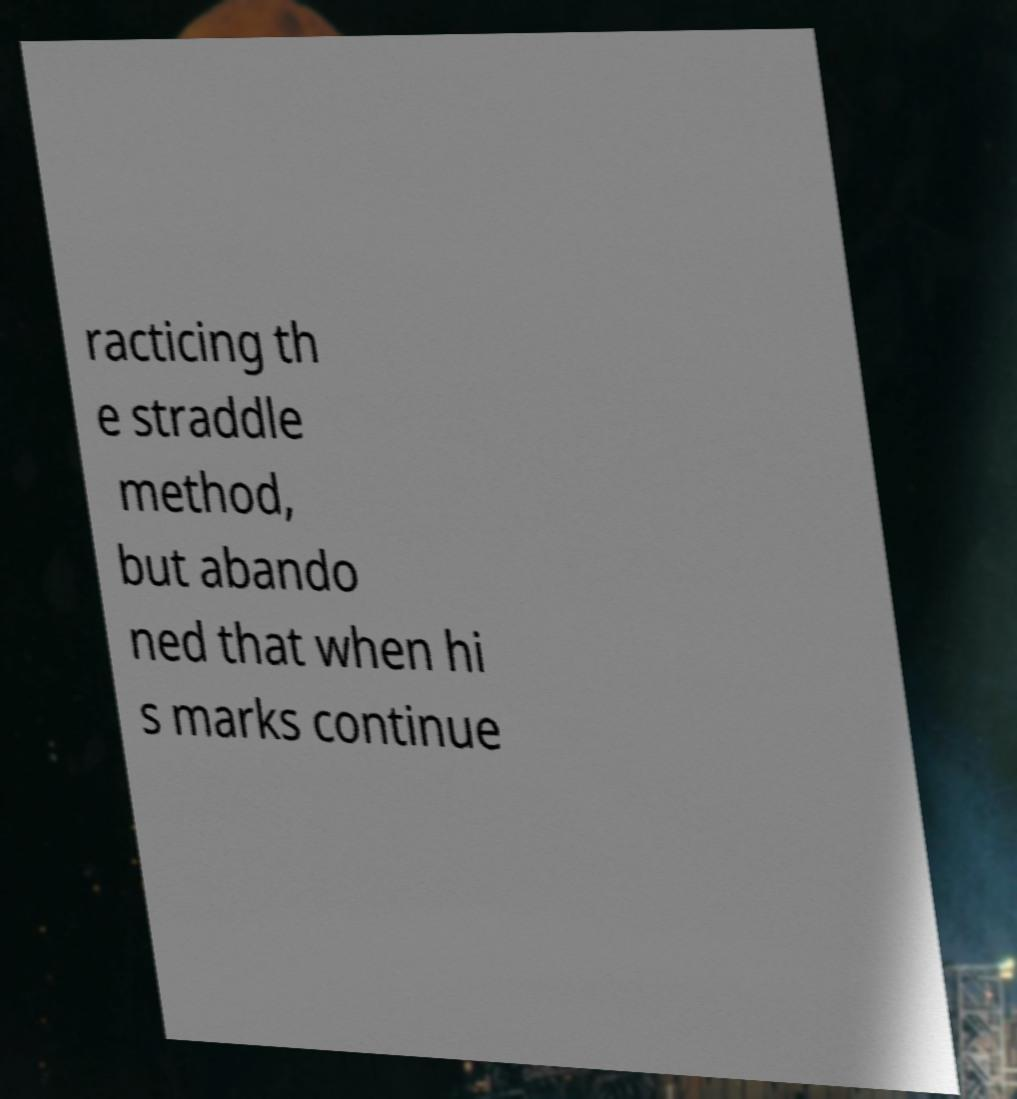Can you read and provide the text displayed in the image?This photo seems to have some interesting text. Can you extract and type it out for me? racticing th e straddle method, but abando ned that when hi s marks continue 